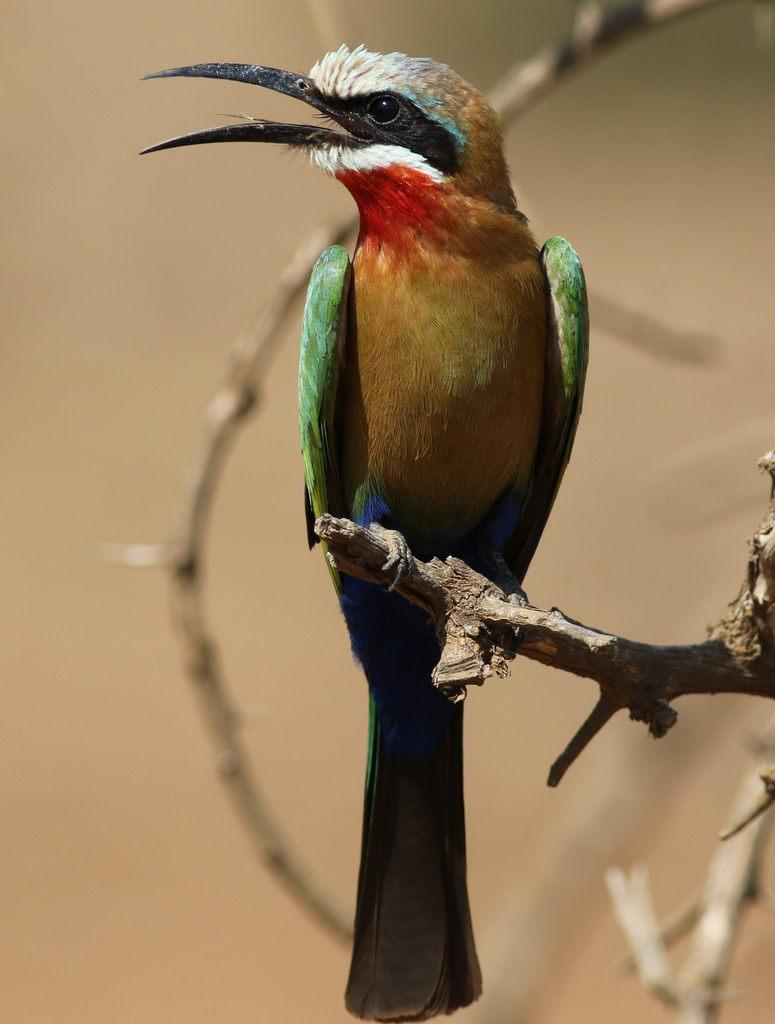What type of animal can be seen in the image? There is a bird in the image. Where is the bird located in the image? The bird is on a branch of a tree. How many sisters does the bird have in the image? There is no information about the bird's sisters in the image, as it only shows a bird on a branch of a tree. 